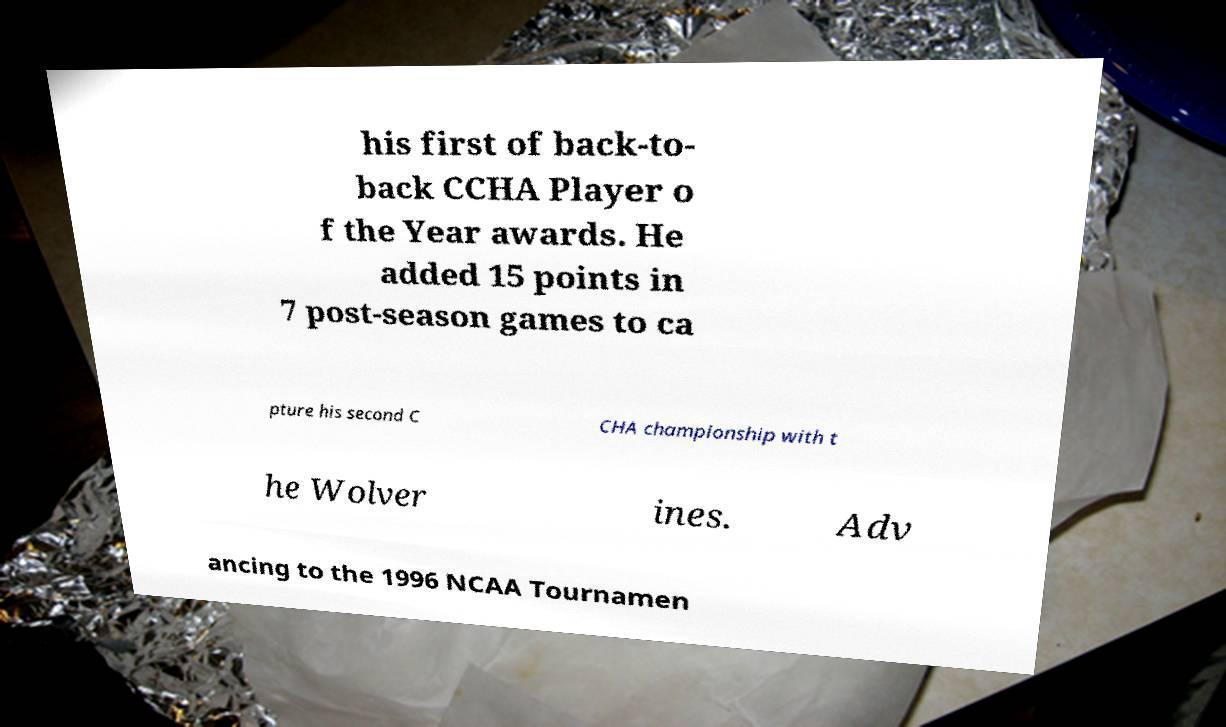Can you read and provide the text displayed in the image?This photo seems to have some interesting text. Can you extract and type it out for me? his first of back-to- back CCHA Player o f the Year awards. He added 15 points in 7 post-season games to ca pture his second C CHA championship with t he Wolver ines. Adv ancing to the 1996 NCAA Tournamen 